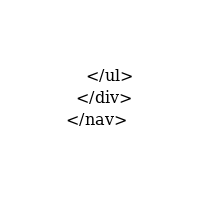Convert code to text. <code><loc_0><loc_0><loc_500><loc_500><_HTML_>    </ul>
  </div>
</nav></code> 